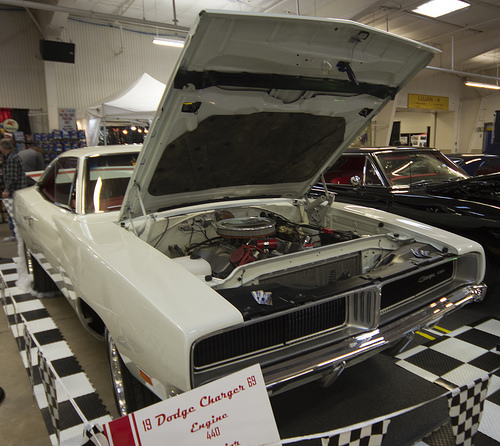<image>
Is the flag under the car? No. The flag is not positioned under the car. The vertical relationship between these objects is different. Is the canopy behind the charger? Yes. From this viewpoint, the canopy is positioned behind the charger, with the charger partially or fully occluding the canopy. 